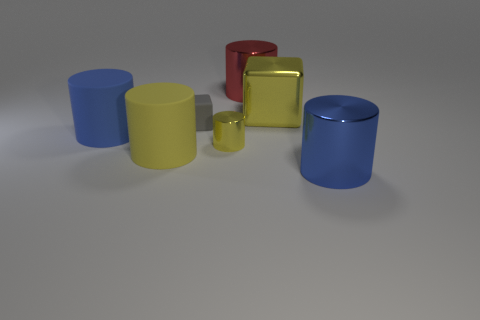Subtract all large shiny cylinders. How many cylinders are left? 3 Subtract all blue cylinders. How many cylinders are left? 3 Subtract all red cylinders. Subtract all green balls. How many cylinders are left? 4 Add 2 big blue metal things. How many objects exist? 9 Subtract all cubes. How many objects are left? 5 Add 6 gray objects. How many gray objects exist? 7 Subtract 2 blue cylinders. How many objects are left? 5 Subtract all brown metal objects. Subtract all big red shiny cylinders. How many objects are left? 6 Add 5 large yellow cylinders. How many large yellow cylinders are left? 6 